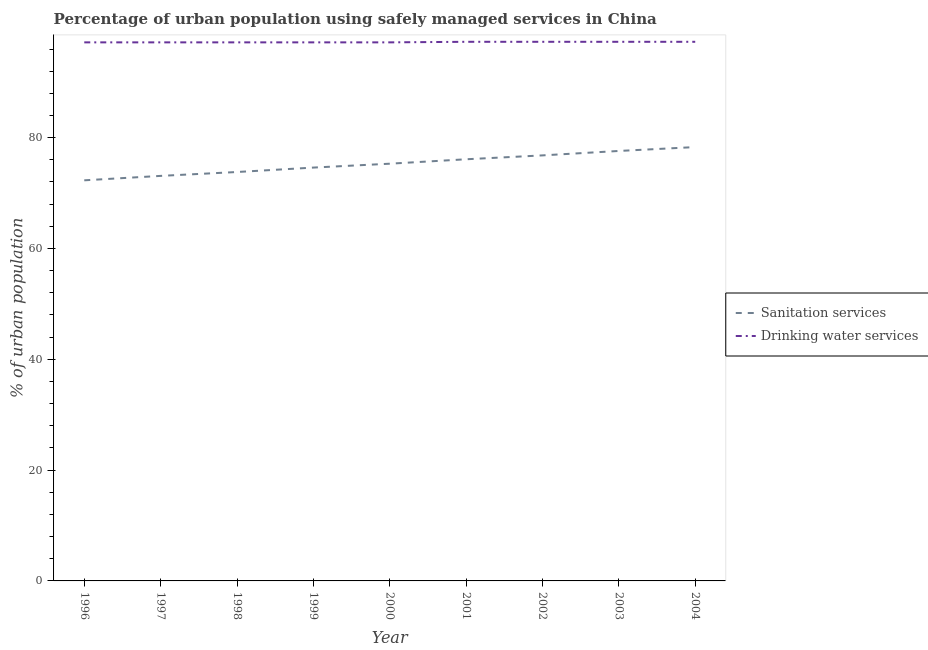How many different coloured lines are there?
Your response must be concise. 2. Does the line corresponding to percentage of urban population who used drinking water services intersect with the line corresponding to percentage of urban population who used sanitation services?
Your response must be concise. No. What is the percentage of urban population who used sanitation services in 2001?
Provide a succinct answer. 76.1. Across all years, what is the maximum percentage of urban population who used sanitation services?
Give a very brief answer. 78.3. Across all years, what is the minimum percentage of urban population who used sanitation services?
Provide a short and direct response. 72.3. In which year was the percentage of urban population who used drinking water services maximum?
Provide a succinct answer. 2001. What is the total percentage of urban population who used drinking water services in the graph?
Offer a very short reply. 875.2. What is the difference between the percentage of urban population who used sanitation services in 1998 and that in 2004?
Offer a very short reply. -4.5. What is the difference between the percentage of urban population who used sanitation services in 2004 and the percentage of urban population who used drinking water services in 1996?
Offer a terse response. -18.9. What is the average percentage of urban population who used sanitation services per year?
Provide a succinct answer. 75.32. In the year 2001, what is the difference between the percentage of urban population who used sanitation services and percentage of urban population who used drinking water services?
Provide a short and direct response. -21.2. In how many years, is the percentage of urban population who used drinking water services greater than 36 %?
Your answer should be very brief. 9. What is the ratio of the percentage of urban population who used drinking water services in 1996 to that in 2003?
Give a very brief answer. 1. Is the difference between the percentage of urban population who used drinking water services in 1996 and 2002 greater than the difference between the percentage of urban population who used sanitation services in 1996 and 2002?
Provide a succinct answer. Yes. What is the difference between the highest and the second highest percentage of urban population who used sanitation services?
Ensure brevity in your answer.  0.7. Does the percentage of urban population who used sanitation services monotonically increase over the years?
Provide a succinct answer. Yes. Is the percentage of urban population who used drinking water services strictly greater than the percentage of urban population who used sanitation services over the years?
Offer a very short reply. Yes. Is the percentage of urban population who used drinking water services strictly less than the percentage of urban population who used sanitation services over the years?
Keep it short and to the point. No. Are the values on the major ticks of Y-axis written in scientific E-notation?
Provide a short and direct response. No. Does the graph contain grids?
Keep it short and to the point. No. Where does the legend appear in the graph?
Offer a very short reply. Center right. How many legend labels are there?
Keep it short and to the point. 2. How are the legend labels stacked?
Offer a terse response. Vertical. What is the title of the graph?
Make the answer very short. Percentage of urban population using safely managed services in China. Does "Domestic Liabilities" appear as one of the legend labels in the graph?
Provide a short and direct response. No. What is the label or title of the Y-axis?
Your response must be concise. % of urban population. What is the % of urban population in Sanitation services in 1996?
Make the answer very short. 72.3. What is the % of urban population in Drinking water services in 1996?
Provide a short and direct response. 97.2. What is the % of urban population of Sanitation services in 1997?
Offer a very short reply. 73.1. What is the % of urban population in Drinking water services in 1997?
Offer a very short reply. 97.2. What is the % of urban population of Sanitation services in 1998?
Your answer should be very brief. 73.8. What is the % of urban population in Drinking water services in 1998?
Offer a terse response. 97.2. What is the % of urban population of Sanitation services in 1999?
Your response must be concise. 74.6. What is the % of urban population in Drinking water services in 1999?
Offer a terse response. 97.2. What is the % of urban population in Sanitation services in 2000?
Your answer should be compact. 75.3. What is the % of urban population in Drinking water services in 2000?
Your answer should be very brief. 97.2. What is the % of urban population in Sanitation services in 2001?
Your answer should be very brief. 76.1. What is the % of urban population in Drinking water services in 2001?
Provide a succinct answer. 97.3. What is the % of urban population in Sanitation services in 2002?
Provide a succinct answer. 76.8. What is the % of urban population of Drinking water services in 2002?
Offer a very short reply. 97.3. What is the % of urban population of Sanitation services in 2003?
Keep it short and to the point. 77.6. What is the % of urban population of Drinking water services in 2003?
Offer a terse response. 97.3. What is the % of urban population of Sanitation services in 2004?
Keep it short and to the point. 78.3. What is the % of urban population in Drinking water services in 2004?
Make the answer very short. 97.3. Across all years, what is the maximum % of urban population in Sanitation services?
Your response must be concise. 78.3. Across all years, what is the maximum % of urban population of Drinking water services?
Make the answer very short. 97.3. Across all years, what is the minimum % of urban population of Sanitation services?
Your response must be concise. 72.3. Across all years, what is the minimum % of urban population in Drinking water services?
Offer a terse response. 97.2. What is the total % of urban population in Sanitation services in the graph?
Your answer should be compact. 677.9. What is the total % of urban population in Drinking water services in the graph?
Offer a terse response. 875.2. What is the difference between the % of urban population in Drinking water services in 1996 and that in 1998?
Offer a very short reply. 0. What is the difference between the % of urban population of Sanitation services in 1996 and that in 2001?
Your answer should be compact. -3.8. What is the difference between the % of urban population in Drinking water services in 1996 and that in 2001?
Offer a very short reply. -0.1. What is the difference between the % of urban population of Drinking water services in 1996 and that in 2002?
Give a very brief answer. -0.1. What is the difference between the % of urban population in Drinking water services in 1996 and that in 2004?
Your answer should be very brief. -0.1. What is the difference between the % of urban population in Drinking water services in 1997 and that in 1998?
Provide a short and direct response. 0. What is the difference between the % of urban population in Drinking water services in 1997 and that in 1999?
Offer a very short reply. 0. What is the difference between the % of urban population of Drinking water services in 1997 and that in 2000?
Offer a very short reply. 0. What is the difference between the % of urban population of Sanitation services in 1997 and that in 2002?
Provide a succinct answer. -3.7. What is the difference between the % of urban population in Sanitation services in 1997 and that in 2003?
Offer a terse response. -4.5. What is the difference between the % of urban population of Drinking water services in 1997 and that in 2003?
Your response must be concise. -0.1. What is the difference between the % of urban population of Sanitation services in 1997 and that in 2004?
Offer a very short reply. -5.2. What is the difference between the % of urban population of Sanitation services in 1998 and that in 1999?
Make the answer very short. -0.8. What is the difference between the % of urban population of Drinking water services in 1998 and that in 1999?
Your answer should be very brief. 0. What is the difference between the % of urban population in Sanitation services in 1998 and that in 2000?
Your response must be concise. -1.5. What is the difference between the % of urban population of Drinking water services in 1998 and that in 2000?
Provide a short and direct response. 0. What is the difference between the % of urban population in Sanitation services in 1998 and that in 2001?
Your answer should be very brief. -2.3. What is the difference between the % of urban population in Drinking water services in 1998 and that in 2001?
Provide a short and direct response. -0.1. What is the difference between the % of urban population in Drinking water services in 1998 and that in 2002?
Give a very brief answer. -0.1. What is the difference between the % of urban population of Sanitation services in 1998 and that in 2003?
Give a very brief answer. -3.8. What is the difference between the % of urban population of Sanitation services in 1998 and that in 2004?
Offer a terse response. -4.5. What is the difference between the % of urban population of Drinking water services in 1998 and that in 2004?
Provide a short and direct response. -0.1. What is the difference between the % of urban population of Sanitation services in 1999 and that in 2002?
Offer a terse response. -2.2. What is the difference between the % of urban population of Drinking water services in 1999 and that in 2002?
Your answer should be compact. -0.1. What is the difference between the % of urban population in Sanitation services in 1999 and that in 2003?
Give a very brief answer. -3. What is the difference between the % of urban population in Drinking water services in 1999 and that in 2004?
Offer a terse response. -0.1. What is the difference between the % of urban population in Sanitation services in 2000 and that in 2001?
Ensure brevity in your answer.  -0.8. What is the difference between the % of urban population in Sanitation services in 2000 and that in 2002?
Your answer should be very brief. -1.5. What is the difference between the % of urban population in Sanitation services in 2000 and that in 2003?
Keep it short and to the point. -2.3. What is the difference between the % of urban population of Drinking water services in 2000 and that in 2003?
Ensure brevity in your answer.  -0.1. What is the difference between the % of urban population in Drinking water services in 2000 and that in 2004?
Provide a succinct answer. -0.1. What is the difference between the % of urban population in Drinking water services in 2001 and that in 2002?
Offer a very short reply. 0. What is the difference between the % of urban population of Drinking water services in 2001 and that in 2003?
Keep it short and to the point. 0. What is the difference between the % of urban population in Drinking water services in 2001 and that in 2004?
Offer a very short reply. 0. What is the difference between the % of urban population in Sanitation services in 2002 and that in 2003?
Make the answer very short. -0.8. What is the difference between the % of urban population in Drinking water services in 2002 and that in 2004?
Offer a terse response. 0. What is the difference between the % of urban population of Drinking water services in 2003 and that in 2004?
Keep it short and to the point. 0. What is the difference between the % of urban population of Sanitation services in 1996 and the % of urban population of Drinking water services in 1997?
Offer a very short reply. -24.9. What is the difference between the % of urban population of Sanitation services in 1996 and the % of urban population of Drinking water services in 1998?
Give a very brief answer. -24.9. What is the difference between the % of urban population in Sanitation services in 1996 and the % of urban population in Drinking water services in 1999?
Provide a succinct answer. -24.9. What is the difference between the % of urban population in Sanitation services in 1996 and the % of urban population in Drinking water services in 2000?
Ensure brevity in your answer.  -24.9. What is the difference between the % of urban population in Sanitation services in 1996 and the % of urban population in Drinking water services in 2001?
Offer a very short reply. -25. What is the difference between the % of urban population of Sanitation services in 1996 and the % of urban population of Drinking water services in 2003?
Offer a terse response. -25. What is the difference between the % of urban population of Sanitation services in 1997 and the % of urban population of Drinking water services in 1998?
Give a very brief answer. -24.1. What is the difference between the % of urban population in Sanitation services in 1997 and the % of urban population in Drinking water services in 1999?
Provide a short and direct response. -24.1. What is the difference between the % of urban population of Sanitation services in 1997 and the % of urban population of Drinking water services in 2000?
Your answer should be compact. -24.1. What is the difference between the % of urban population in Sanitation services in 1997 and the % of urban population in Drinking water services in 2001?
Keep it short and to the point. -24.2. What is the difference between the % of urban population in Sanitation services in 1997 and the % of urban population in Drinking water services in 2002?
Keep it short and to the point. -24.2. What is the difference between the % of urban population in Sanitation services in 1997 and the % of urban population in Drinking water services in 2003?
Your answer should be compact. -24.2. What is the difference between the % of urban population of Sanitation services in 1997 and the % of urban population of Drinking water services in 2004?
Provide a short and direct response. -24.2. What is the difference between the % of urban population of Sanitation services in 1998 and the % of urban population of Drinking water services in 1999?
Offer a terse response. -23.4. What is the difference between the % of urban population of Sanitation services in 1998 and the % of urban population of Drinking water services in 2000?
Your answer should be very brief. -23.4. What is the difference between the % of urban population of Sanitation services in 1998 and the % of urban population of Drinking water services in 2001?
Keep it short and to the point. -23.5. What is the difference between the % of urban population of Sanitation services in 1998 and the % of urban population of Drinking water services in 2002?
Make the answer very short. -23.5. What is the difference between the % of urban population of Sanitation services in 1998 and the % of urban population of Drinking water services in 2003?
Make the answer very short. -23.5. What is the difference between the % of urban population of Sanitation services in 1998 and the % of urban population of Drinking water services in 2004?
Your answer should be compact. -23.5. What is the difference between the % of urban population of Sanitation services in 1999 and the % of urban population of Drinking water services in 2000?
Give a very brief answer. -22.6. What is the difference between the % of urban population of Sanitation services in 1999 and the % of urban population of Drinking water services in 2001?
Keep it short and to the point. -22.7. What is the difference between the % of urban population in Sanitation services in 1999 and the % of urban population in Drinking water services in 2002?
Provide a succinct answer. -22.7. What is the difference between the % of urban population in Sanitation services in 1999 and the % of urban population in Drinking water services in 2003?
Provide a short and direct response. -22.7. What is the difference between the % of urban population of Sanitation services in 1999 and the % of urban population of Drinking water services in 2004?
Make the answer very short. -22.7. What is the difference between the % of urban population in Sanitation services in 2000 and the % of urban population in Drinking water services in 2003?
Provide a succinct answer. -22. What is the difference between the % of urban population of Sanitation services in 2001 and the % of urban population of Drinking water services in 2002?
Provide a short and direct response. -21.2. What is the difference between the % of urban population in Sanitation services in 2001 and the % of urban population in Drinking water services in 2003?
Your answer should be very brief. -21.2. What is the difference between the % of urban population of Sanitation services in 2001 and the % of urban population of Drinking water services in 2004?
Provide a succinct answer. -21.2. What is the difference between the % of urban population of Sanitation services in 2002 and the % of urban population of Drinking water services in 2003?
Make the answer very short. -20.5. What is the difference between the % of urban population of Sanitation services in 2002 and the % of urban population of Drinking water services in 2004?
Offer a terse response. -20.5. What is the difference between the % of urban population of Sanitation services in 2003 and the % of urban population of Drinking water services in 2004?
Ensure brevity in your answer.  -19.7. What is the average % of urban population of Sanitation services per year?
Give a very brief answer. 75.32. What is the average % of urban population of Drinking water services per year?
Keep it short and to the point. 97.24. In the year 1996, what is the difference between the % of urban population of Sanitation services and % of urban population of Drinking water services?
Your answer should be compact. -24.9. In the year 1997, what is the difference between the % of urban population of Sanitation services and % of urban population of Drinking water services?
Provide a short and direct response. -24.1. In the year 1998, what is the difference between the % of urban population of Sanitation services and % of urban population of Drinking water services?
Keep it short and to the point. -23.4. In the year 1999, what is the difference between the % of urban population in Sanitation services and % of urban population in Drinking water services?
Your answer should be compact. -22.6. In the year 2000, what is the difference between the % of urban population in Sanitation services and % of urban population in Drinking water services?
Your response must be concise. -21.9. In the year 2001, what is the difference between the % of urban population of Sanitation services and % of urban population of Drinking water services?
Provide a short and direct response. -21.2. In the year 2002, what is the difference between the % of urban population in Sanitation services and % of urban population in Drinking water services?
Give a very brief answer. -20.5. In the year 2003, what is the difference between the % of urban population of Sanitation services and % of urban population of Drinking water services?
Offer a very short reply. -19.7. What is the ratio of the % of urban population of Sanitation services in 1996 to that in 1998?
Ensure brevity in your answer.  0.98. What is the ratio of the % of urban population of Sanitation services in 1996 to that in 1999?
Your response must be concise. 0.97. What is the ratio of the % of urban population in Sanitation services in 1996 to that in 2000?
Make the answer very short. 0.96. What is the ratio of the % of urban population in Sanitation services in 1996 to that in 2001?
Ensure brevity in your answer.  0.95. What is the ratio of the % of urban population in Drinking water services in 1996 to that in 2001?
Your response must be concise. 1. What is the ratio of the % of urban population in Sanitation services in 1996 to that in 2002?
Your response must be concise. 0.94. What is the ratio of the % of urban population in Sanitation services in 1996 to that in 2003?
Offer a very short reply. 0.93. What is the ratio of the % of urban population of Drinking water services in 1996 to that in 2003?
Provide a short and direct response. 1. What is the ratio of the % of urban population in Sanitation services in 1996 to that in 2004?
Offer a very short reply. 0.92. What is the ratio of the % of urban population of Drinking water services in 1996 to that in 2004?
Give a very brief answer. 1. What is the ratio of the % of urban population of Drinking water services in 1997 to that in 1998?
Give a very brief answer. 1. What is the ratio of the % of urban population in Sanitation services in 1997 to that in 1999?
Keep it short and to the point. 0.98. What is the ratio of the % of urban population in Sanitation services in 1997 to that in 2000?
Offer a terse response. 0.97. What is the ratio of the % of urban population of Drinking water services in 1997 to that in 2000?
Offer a terse response. 1. What is the ratio of the % of urban population in Sanitation services in 1997 to that in 2001?
Your response must be concise. 0.96. What is the ratio of the % of urban population in Drinking water services in 1997 to that in 2001?
Your answer should be very brief. 1. What is the ratio of the % of urban population in Sanitation services in 1997 to that in 2002?
Your answer should be compact. 0.95. What is the ratio of the % of urban population of Sanitation services in 1997 to that in 2003?
Your response must be concise. 0.94. What is the ratio of the % of urban population of Drinking water services in 1997 to that in 2003?
Your response must be concise. 1. What is the ratio of the % of urban population in Sanitation services in 1997 to that in 2004?
Offer a very short reply. 0.93. What is the ratio of the % of urban population of Drinking water services in 1997 to that in 2004?
Your answer should be compact. 1. What is the ratio of the % of urban population in Sanitation services in 1998 to that in 1999?
Your answer should be compact. 0.99. What is the ratio of the % of urban population of Sanitation services in 1998 to that in 2000?
Make the answer very short. 0.98. What is the ratio of the % of urban population of Drinking water services in 1998 to that in 2000?
Your response must be concise. 1. What is the ratio of the % of urban population in Sanitation services in 1998 to that in 2001?
Your answer should be very brief. 0.97. What is the ratio of the % of urban population in Sanitation services in 1998 to that in 2002?
Offer a very short reply. 0.96. What is the ratio of the % of urban population in Sanitation services in 1998 to that in 2003?
Give a very brief answer. 0.95. What is the ratio of the % of urban population in Drinking water services in 1998 to that in 2003?
Your answer should be compact. 1. What is the ratio of the % of urban population of Sanitation services in 1998 to that in 2004?
Provide a short and direct response. 0.94. What is the ratio of the % of urban population in Sanitation services in 1999 to that in 2001?
Your response must be concise. 0.98. What is the ratio of the % of urban population of Sanitation services in 1999 to that in 2002?
Your answer should be very brief. 0.97. What is the ratio of the % of urban population in Sanitation services in 1999 to that in 2003?
Provide a short and direct response. 0.96. What is the ratio of the % of urban population in Drinking water services in 1999 to that in 2003?
Your answer should be very brief. 1. What is the ratio of the % of urban population of Sanitation services in 1999 to that in 2004?
Provide a short and direct response. 0.95. What is the ratio of the % of urban population in Sanitation services in 2000 to that in 2001?
Ensure brevity in your answer.  0.99. What is the ratio of the % of urban population in Drinking water services in 2000 to that in 2001?
Provide a succinct answer. 1. What is the ratio of the % of urban population of Sanitation services in 2000 to that in 2002?
Your response must be concise. 0.98. What is the ratio of the % of urban population of Drinking water services in 2000 to that in 2002?
Your response must be concise. 1. What is the ratio of the % of urban population of Sanitation services in 2000 to that in 2003?
Offer a terse response. 0.97. What is the ratio of the % of urban population in Drinking water services in 2000 to that in 2003?
Make the answer very short. 1. What is the ratio of the % of urban population in Sanitation services in 2000 to that in 2004?
Provide a succinct answer. 0.96. What is the ratio of the % of urban population of Drinking water services in 2000 to that in 2004?
Your answer should be compact. 1. What is the ratio of the % of urban population in Sanitation services in 2001 to that in 2002?
Make the answer very short. 0.99. What is the ratio of the % of urban population of Drinking water services in 2001 to that in 2002?
Ensure brevity in your answer.  1. What is the ratio of the % of urban population of Sanitation services in 2001 to that in 2003?
Your response must be concise. 0.98. What is the ratio of the % of urban population in Sanitation services in 2001 to that in 2004?
Your answer should be very brief. 0.97. What is the ratio of the % of urban population of Drinking water services in 2001 to that in 2004?
Ensure brevity in your answer.  1. What is the ratio of the % of urban population in Drinking water services in 2002 to that in 2003?
Make the answer very short. 1. What is the ratio of the % of urban population of Sanitation services in 2002 to that in 2004?
Keep it short and to the point. 0.98. What is the ratio of the % of urban population in Sanitation services in 2003 to that in 2004?
Offer a very short reply. 0.99. What is the difference between the highest and the second highest % of urban population of Sanitation services?
Give a very brief answer. 0.7. What is the difference between the highest and the second highest % of urban population in Drinking water services?
Your answer should be compact. 0. What is the difference between the highest and the lowest % of urban population of Sanitation services?
Provide a succinct answer. 6. 